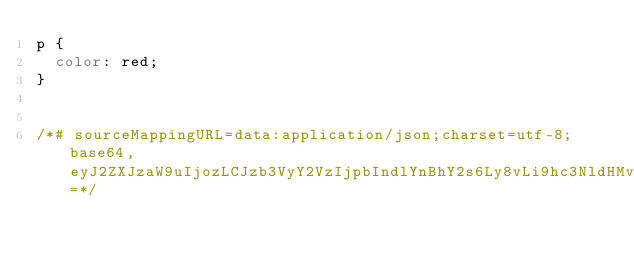Convert code to text. <code><loc_0><loc_0><loc_500><loc_500><_CSS_>p {
  color: red;
}


/*# sourceMappingURL=data:application/json;charset=utf-8;base64,eyJ2ZXJzaW9uIjozLCJzb3VyY2VzIjpbIndlYnBhY2s6Ly8vLi9hc3NldHMvY3NzL21haW4uY3NzIl0sIm5hbWVzIjpbXSwibWFwcGluZ3MiOiI7QUFDQTtBQUNBO0FBQ0EiLCJmaWxlIjoiY3NzL21haW4uY3NzIiwic291cmNlc0NvbnRlbnQiOlsiXG5wIHtcbiAgY29sb3I6IHJlZDtcbn1cbiJdLCJzb3VyY2VSb290IjoiIn0=*/</code> 